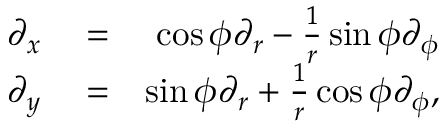<formula> <loc_0><loc_0><loc_500><loc_500>\begin{array} { r l r } { \partial _ { x } } & = } & { \cos \phi \partial _ { r } - \frac { 1 } { r } \sin \phi \partial _ { \phi } } \\ { \partial _ { y } } & = } & { \sin \phi \partial _ { r } + \frac { 1 } { r } \cos \phi \partial _ { \phi } , } \end{array}</formula> 